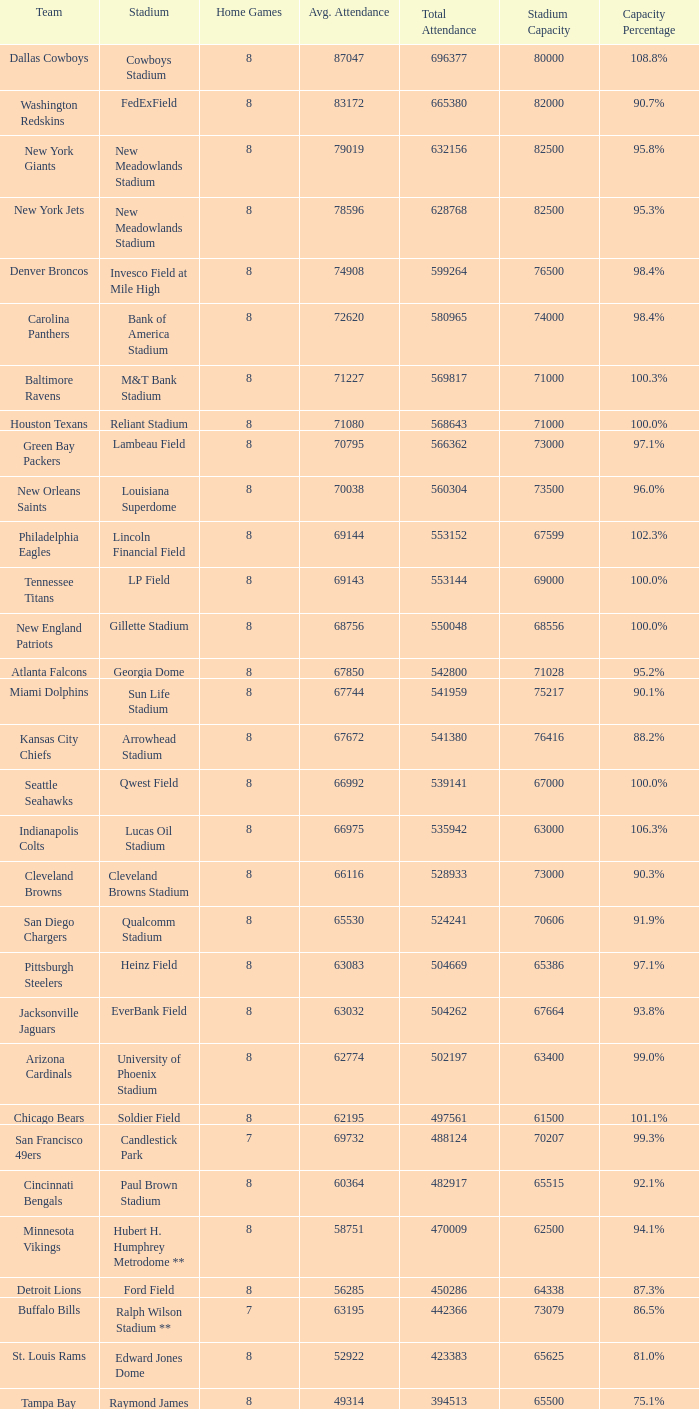What was average attendance when total attendance was 541380? 67672.0. 